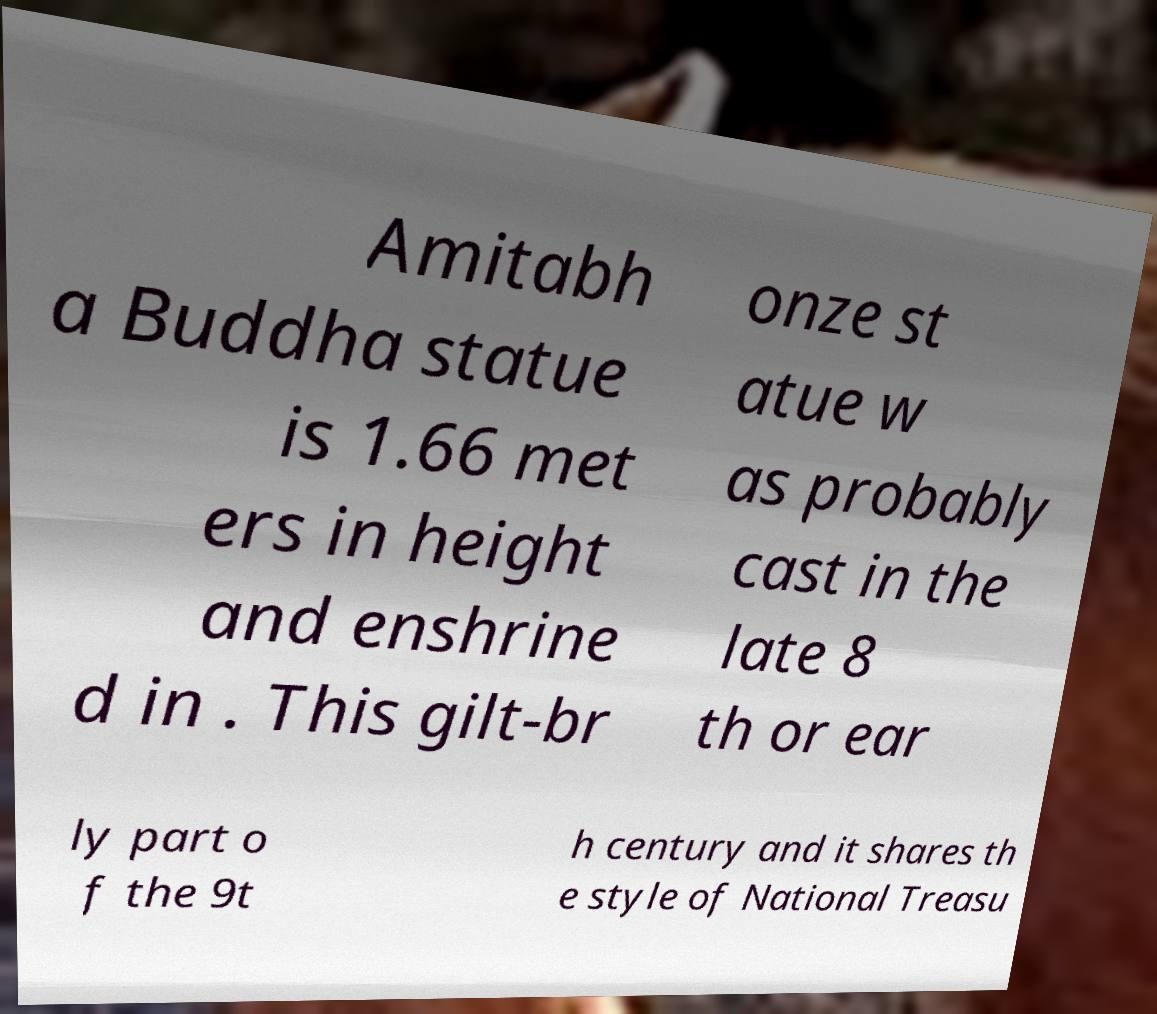What messages or text are displayed in this image? I need them in a readable, typed format. Amitabh a Buddha statue is 1.66 met ers in height and enshrine d in . This gilt-br onze st atue w as probably cast in the late 8 th or ear ly part o f the 9t h century and it shares th e style of National Treasu 